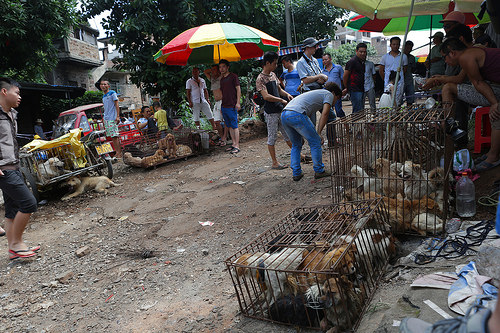<image>
Is the dog under the cage? Yes. The dog is positioned underneath the cage, with the cage above it in the vertical space. Is the dog to the right of the man? No. The dog is not to the right of the man. The horizontal positioning shows a different relationship. 